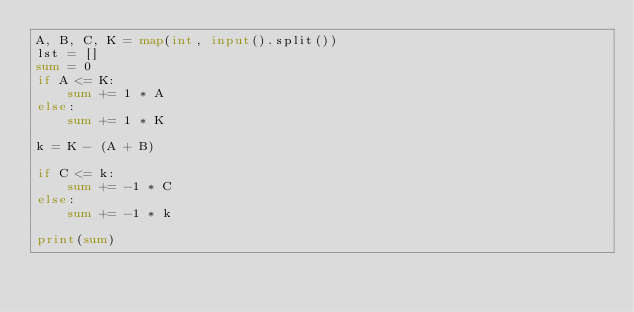<code> <loc_0><loc_0><loc_500><loc_500><_Python_>A, B, C, K = map(int, input().split())
lst = []
sum = 0
if A <= K:
    sum += 1 * A
else:
    sum += 1 * K

k = K - (A + B)

if C <= k:
    sum += -1 * C
else:
    sum += -1 * k

print(sum)</code> 